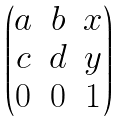<formula> <loc_0><loc_0><loc_500><loc_500>\begin{pmatrix} a & b & x \\ c & d & y \\ 0 & 0 & 1 \end{pmatrix}</formula> 